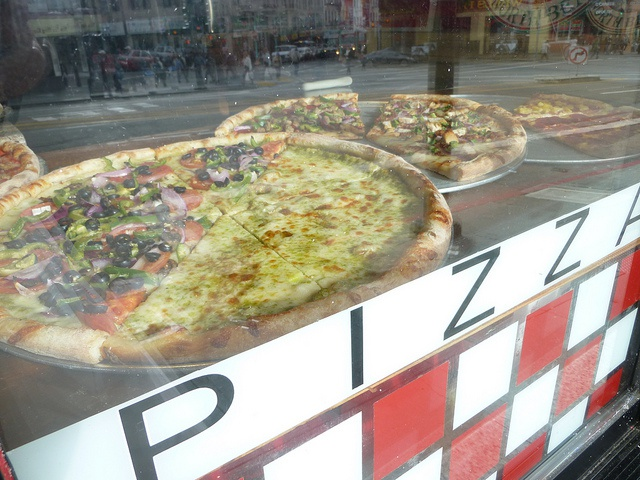Describe the objects in this image and their specific colors. I can see pizza in black, tan, khaki, darkgray, and gray tones, pizza in black, tan, darkgray, and gray tones, pizza in purple, tan, darkgray, and gray tones, pizza in black, tan, and gray tones, and pizza in black, gray, and tan tones in this image. 